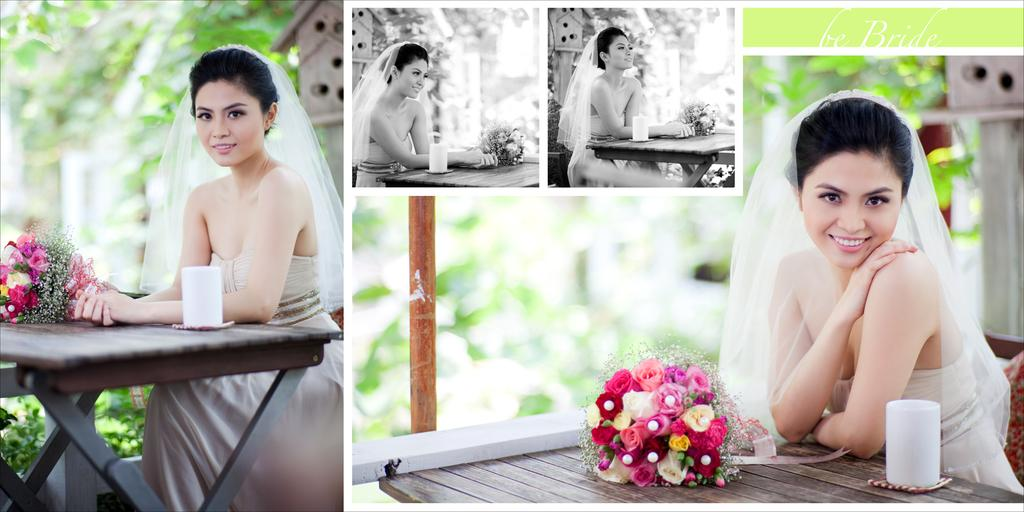What type of artwork is depicted in the image? The image appears to be a collage. Can you describe the woman in the image? There is a woman sitting on a bench in the image. What can be seen on the table in the image? There is a table with a flower bouquet in the image, and there are objects placed on the table. What kind of structure is visible in the image? There is a wooden bird house in the image. How many boys are playing with the pet in the image? There are no boys or pets present in the image. What type of lunch is being served on the table in the image? There is no lunch visible in the image; only a table with a flower bouquet and other objects is present. 